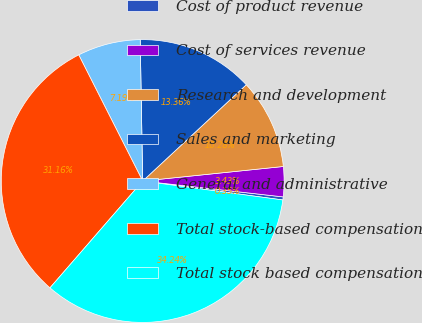<chart> <loc_0><loc_0><loc_500><loc_500><pie_chart><fcel>Cost of product revenue<fcel>Cost of services revenue<fcel>Research and development<fcel>Sales and marketing<fcel>General and administrative<fcel>Total stock-based compensation<fcel>Total stock based compensation<nl><fcel>0.35%<fcel>3.43%<fcel>10.28%<fcel>13.36%<fcel>7.19%<fcel>31.16%<fcel>34.24%<nl></chart> 